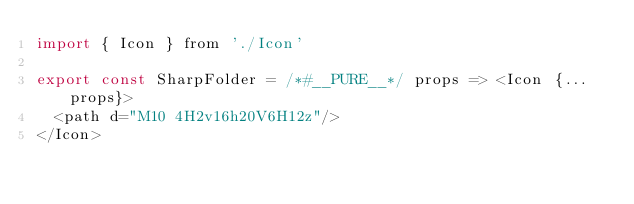<code> <loc_0><loc_0><loc_500><loc_500><_JavaScript_>import { Icon } from './Icon'

export const SharpFolder = /*#__PURE__*/ props => <Icon {...props}>
  <path d="M10 4H2v16h20V6H12z"/>
</Icon>
</code> 